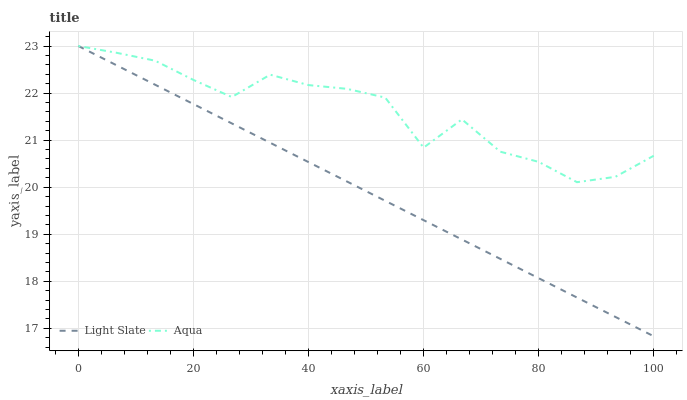Does Light Slate have the minimum area under the curve?
Answer yes or no. Yes. Does Aqua have the maximum area under the curve?
Answer yes or no. Yes. Does Aqua have the minimum area under the curve?
Answer yes or no. No. Is Light Slate the smoothest?
Answer yes or no. Yes. Is Aqua the roughest?
Answer yes or no. Yes. Is Aqua the smoothest?
Answer yes or no. No. Does Light Slate have the lowest value?
Answer yes or no. Yes. Does Aqua have the lowest value?
Answer yes or no. No. Does Aqua have the highest value?
Answer yes or no. Yes. Does Aqua intersect Light Slate?
Answer yes or no. Yes. Is Aqua less than Light Slate?
Answer yes or no. No. Is Aqua greater than Light Slate?
Answer yes or no. No. 